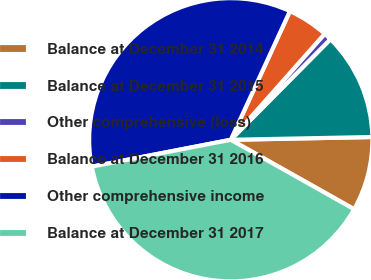Convert chart. <chart><loc_0><loc_0><loc_500><loc_500><pie_chart><fcel>Balance at December 31 2014<fcel>Balance at December 31 2015<fcel>Other comprehensive (loss)<fcel>Balance at December 31 2016<fcel>Other comprehensive income<fcel>Balance at December 31 2017<nl><fcel>8.47%<fcel>12.26%<fcel>0.89%<fcel>4.68%<fcel>34.9%<fcel>38.8%<nl></chart> 